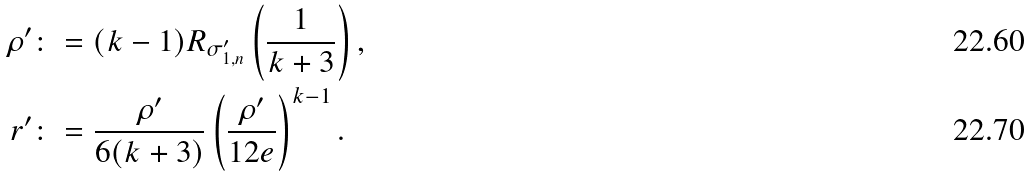Convert formula to latex. <formula><loc_0><loc_0><loc_500><loc_500>\rho ^ { \prime } & \colon = ( k - 1 ) R _ { \sigma _ { 1 , n } ^ { \prime } } \left ( \frac { 1 } { k + 3 } \right ) , \\ r ^ { \prime } & \colon = \frac { \rho ^ { \prime } } { 6 ( k + 3 ) } \left ( \frac { \rho ^ { \prime } } { 1 2 e } \right ) ^ { k - 1 } .</formula> 